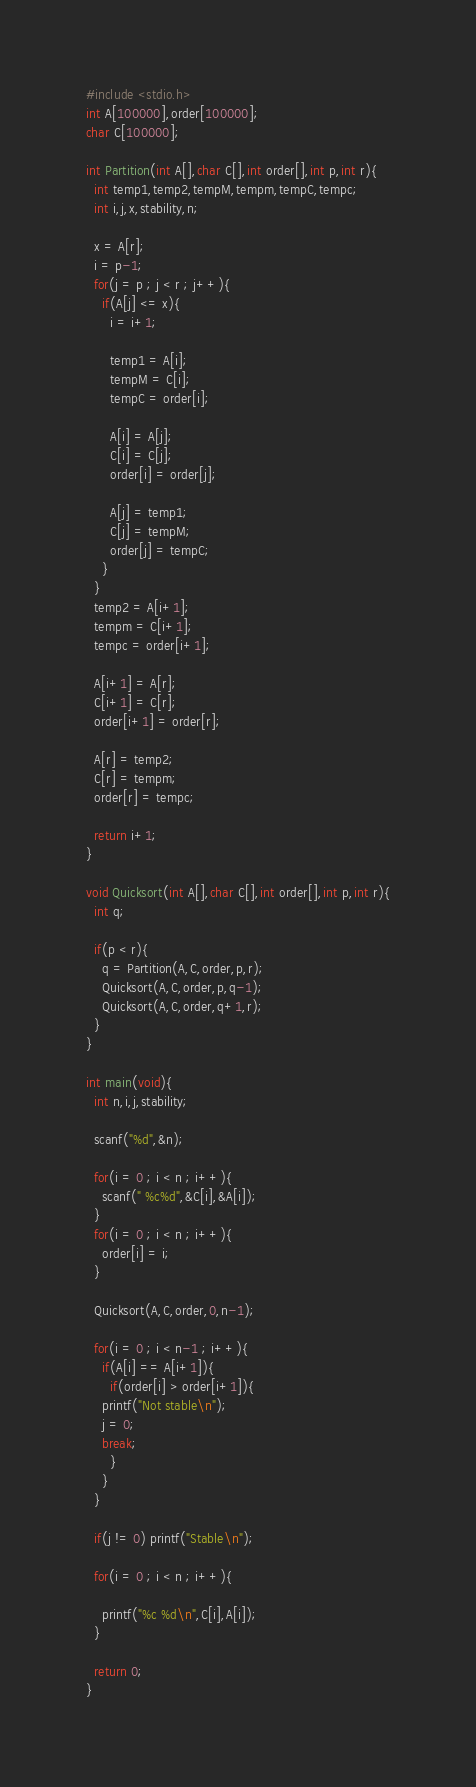Convert code to text. <code><loc_0><loc_0><loc_500><loc_500><_C_>#include <stdio.h>
int A[100000],order[100000];
char C[100000];

int Partition(int A[],char C[],int order[],int p,int r){
  int temp1,temp2,tempM,tempm,tempC,tempc;
  int i,j,x,stability,n;
  
  x = A[r];
  i = p-1;
  for(j = p ; j < r ; j++){
    if(A[j] <= x){
      i = i+1; 
      
      temp1 = A[i];
      tempM = C[i];
      tempC = order[i];
      
      A[i] = A[j];
      C[i] = C[j];
      order[i] = order[j];

      A[j] = temp1;
      C[j] = tempM;
      order[j] = tempC;
    }
  }
  temp2 = A[i+1];
  tempm = C[i+1];
  tempc = order[i+1];

  A[i+1] = A[r];
  C[i+1] = C[r];
  order[i+1] = order[r];

  A[r] = temp2;
  C[r] = tempm;
  order[r] = tempc;

  return i+1;
}

void Quicksort(int A[],char C[],int order[],int p,int r){
  int q;

  if(p < r){
    q = Partition(A,C,order,p,r);
    Quicksort(A,C,order,p,q-1);
    Quicksort(A,C,order,q+1,r);
  }
}

int main(void){
  int n,i,j,stability;

  scanf("%d",&n);
  
  for(i = 0 ; i < n ; i++){
    scanf(" %c%d",&C[i],&A[i]);
  }  
  for(i = 0 ; i < n ; i++){
    order[i] = i;
  }
  
  Quicksort(A,C,order,0,n-1);

  for(i = 0 ; i < n-1 ; i++){
    if(A[i] == A[i+1]){
      if(order[i] > order[i+1]){
	printf("Not stable\n");
	j = 0;
	break;
      }
    }
  }

  if(j != 0) printf("Stable\n");

  for(i = 0 ; i < n ; i++){
    
    printf("%c %d\n",C[i],A[i]);
  }
  
  return 0;
}</code> 